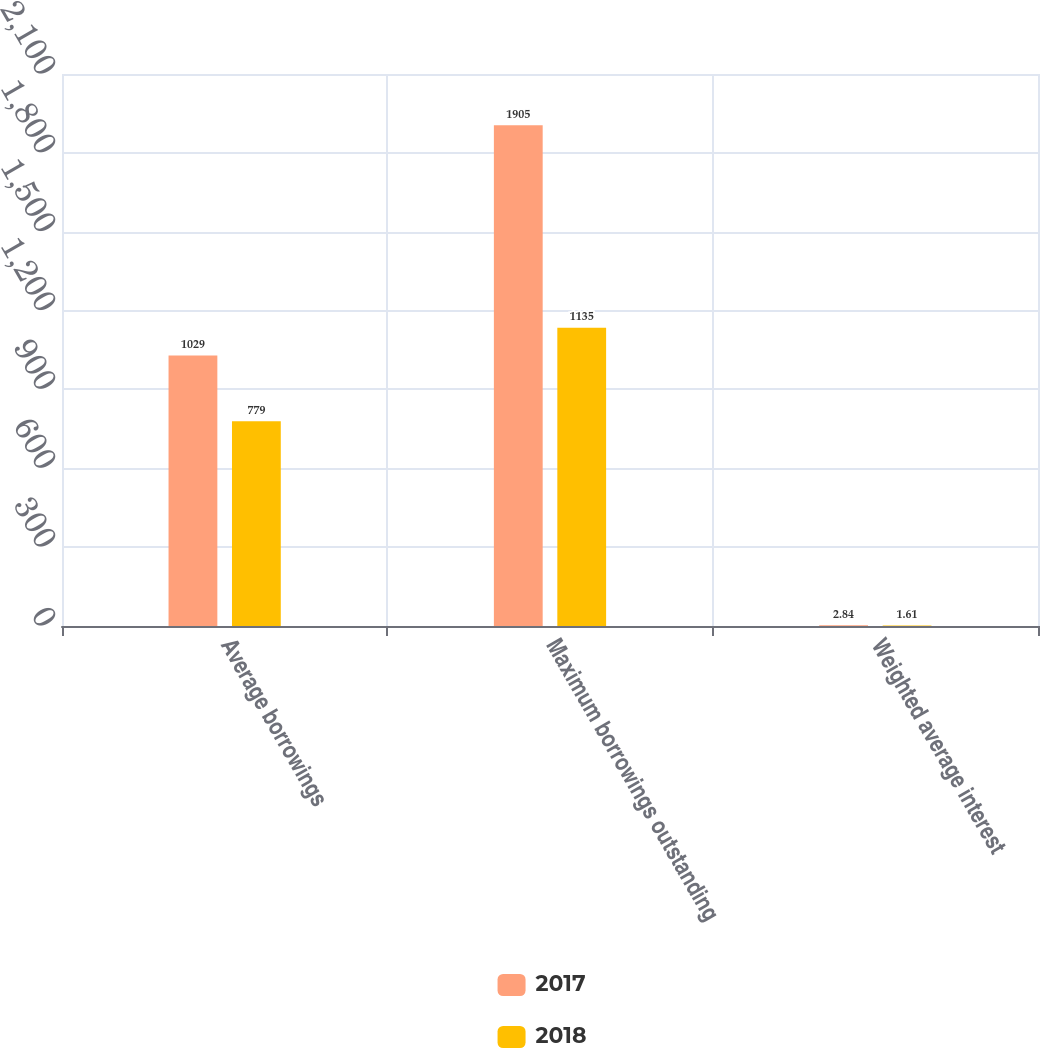<chart> <loc_0><loc_0><loc_500><loc_500><stacked_bar_chart><ecel><fcel>Average borrowings<fcel>Maximum borrowings outstanding<fcel>Weighted average interest<nl><fcel>2017<fcel>1029<fcel>1905<fcel>2.84<nl><fcel>2018<fcel>779<fcel>1135<fcel>1.61<nl></chart> 